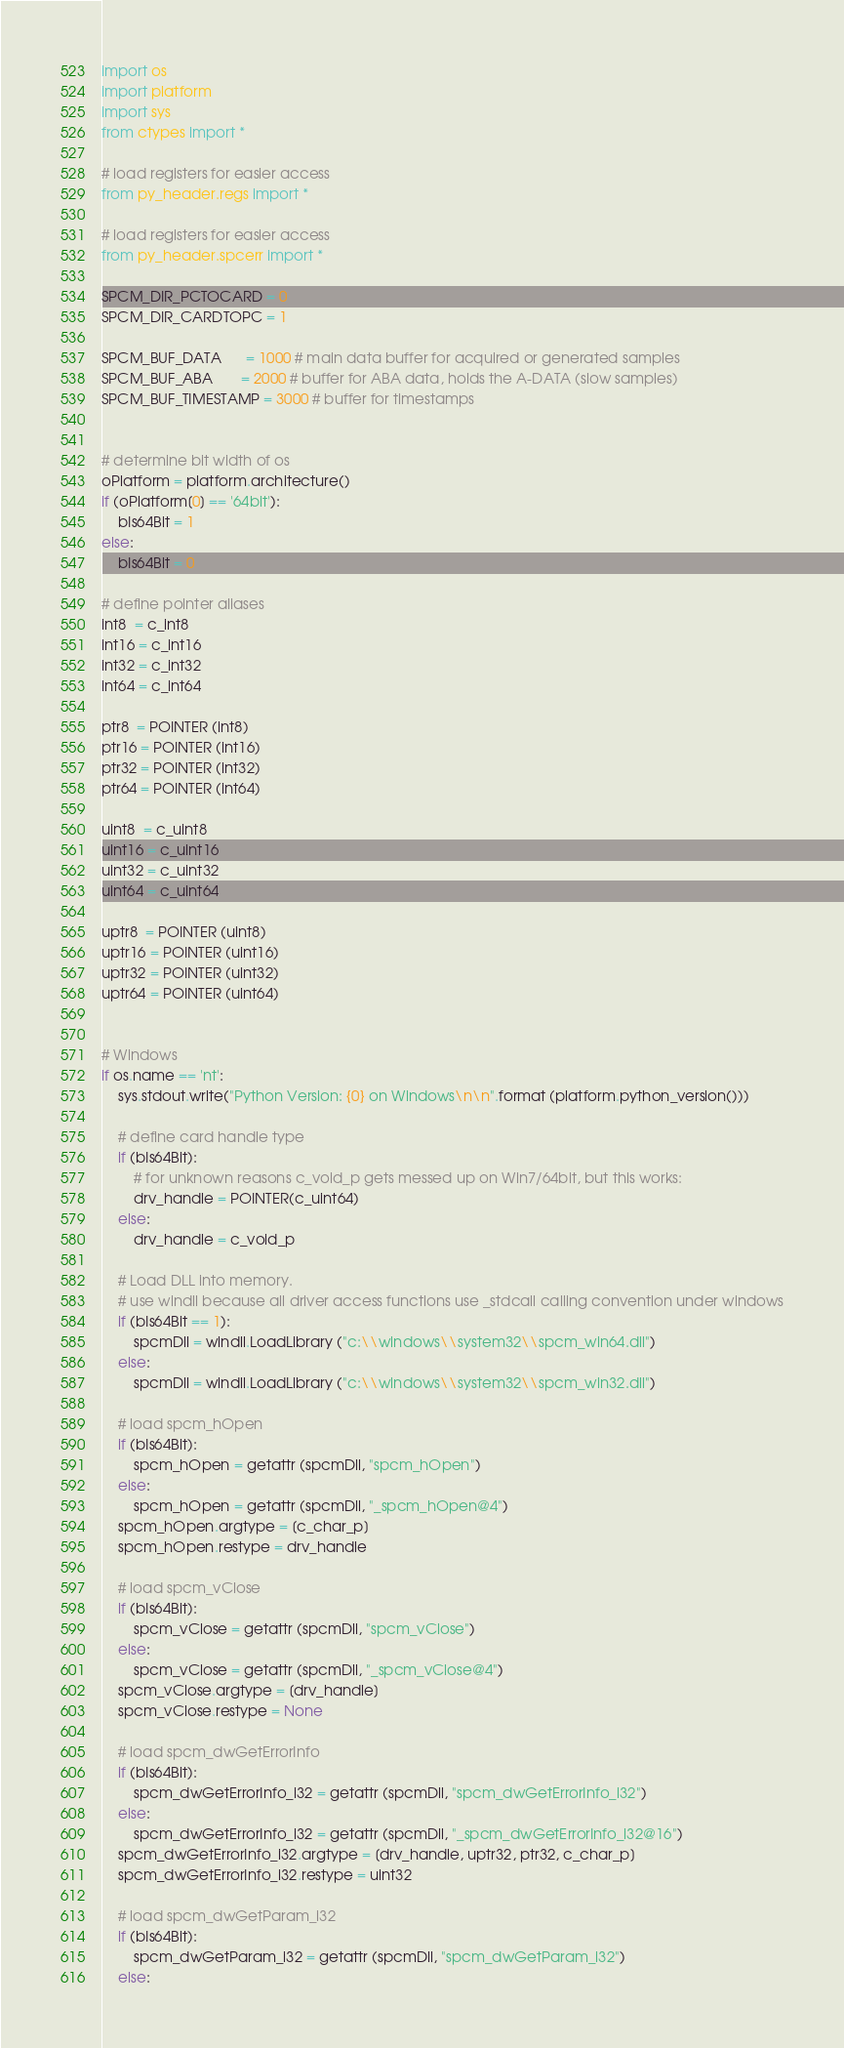Convert code to text. <code><loc_0><loc_0><loc_500><loc_500><_Python_>import os
import platform
import sys 
from ctypes import *

# load registers for easier access
from py_header.regs import *

# load registers for easier access
from py_header.spcerr import *

SPCM_DIR_PCTOCARD = 0
SPCM_DIR_CARDTOPC = 1

SPCM_BUF_DATA      = 1000 # main data buffer for acquired or generated samples
SPCM_BUF_ABA       = 2000 # buffer for ABA data, holds the A-DATA (slow samples)
SPCM_BUF_TIMESTAMP = 3000 # buffer for timestamps


# determine bit width of os
oPlatform = platform.architecture()
if (oPlatform[0] == '64bit'):
    bIs64Bit = 1
else:
    bIs64Bit = 0

# define pointer aliases
int8  = c_int8
int16 = c_int16
int32 = c_int32
int64 = c_int64

ptr8  = POINTER (int8)
ptr16 = POINTER (int16)
ptr32 = POINTER (int32)
ptr64 = POINTER (int64)

uint8  = c_uint8
uint16 = c_uint16
uint32 = c_uint32
uint64 = c_uint64

uptr8  = POINTER (uint8)
uptr16 = POINTER (uint16)
uptr32 = POINTER (uint32)
uptr64 = POINTER (uint64)


# Windows
if os.name == 'nt':
    sys.stdout.write("Python Version: {0} on Windows\n\n".format (platform.python_version()))

    # define card handle type
    if (bIs64Bit):
        # for unknown reasons c_void_p gets messed up on Win7/64bit, but this works:
        drv_handle = POINTER(c_uint64)
    else:
        drv_handle = c_void_p

    # Load DLL into memory.
    # use windll because all driver access functions use _stdcall calling convention under windows
    if (bIs64Bit == 1):
        spcmDll = windll.LoadLibrary ("c:\\windows\\system32\\spcm_win64.dll")
    else:
        spcmDll = windll.LoadLibrary ("c:\\windows\\system32\\spcm_win32.dll")

    # load spcm_hOpen
    if (bIs64Bit):
        spcm_hOpen = getattr (spcmDll, "spcm_hOpen")
    else:
        spcm_hOpen = getattr (spcmDll, "_spcm_hOpen@4")
    spcm_hOpen.argtype = [c_char_p]
    spcm_hOpen.restype = drv_handle 

    # load spcm_vClose
    if (bIs64Bit):
        spcm_vClose = getattr (spcmDll, "spcm_vClose")
    else:
        spcm_vClose = getattr (spcmDll, "_spcm_vClose@4")
    spcm_vClose.argtype = [drv_handle]
    spcm_vClose.restype = None

    # load spcm_dwGetErrorInfo
    if (bIs64Bit):
        spcm_dwGetErrorInfo_i32 = getattr (spcmDll, "spcm_dwGetErrorInfo_i32")
    else:
        spcm_dwGetErrorInfo_i32 = getattr (spcmDll, "_spcm_dwGetErrorInfo_i32@16")
    spcm_dwGetErrorInfo_i32.argtype = [drv_handle, uptr32, ptr32, c_char_p]
    spcm_dwGetErrorInfo_i32.restype = uint32

    # load spcm_dwGetParam_i32
    if (bIs64Bit):
        spcm_dwGetParam_i32 = getattr (spcmDll, "spcm_dwGetParam_i32")
    else:</code> 